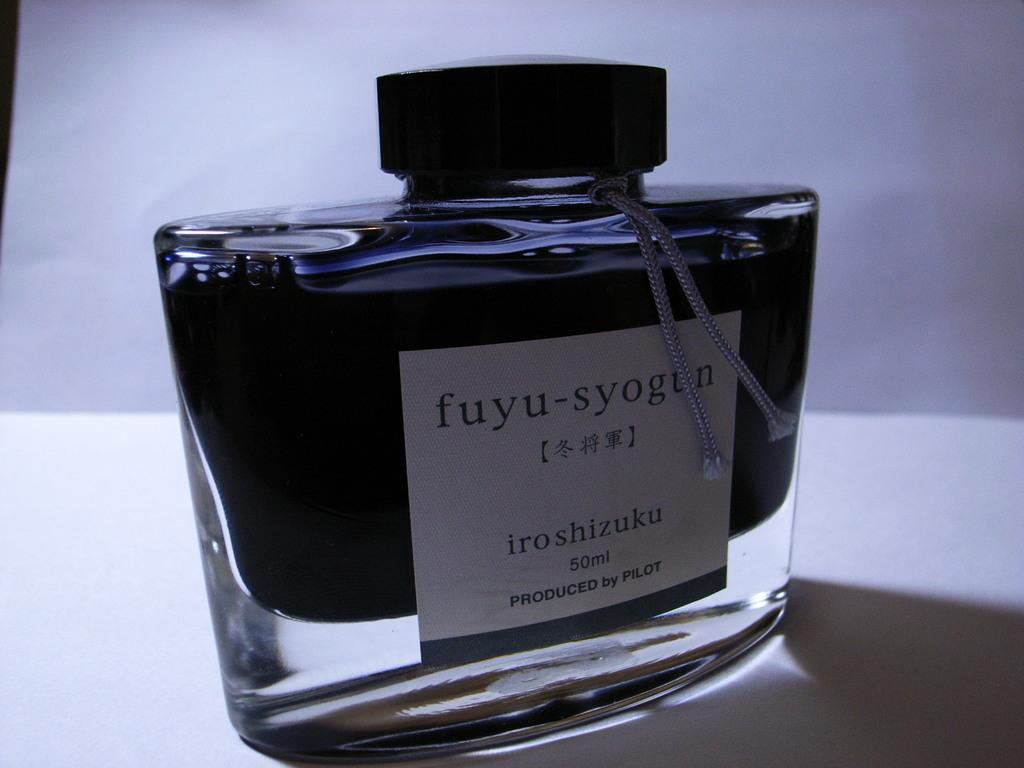<image>
Present a compact description of the photo's key features. A 50ml bottle of fuyu-syogun cologne produced by Pilot. 